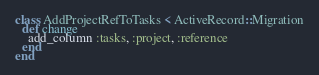<code> <loc_0><loc_0><loc_500><loc_500><_Ruby_>class AddProjectRefToTasks < ActiveRecord::Migration
  def change
    add_column :tasks, :project, :reference
  end
end
</code> 